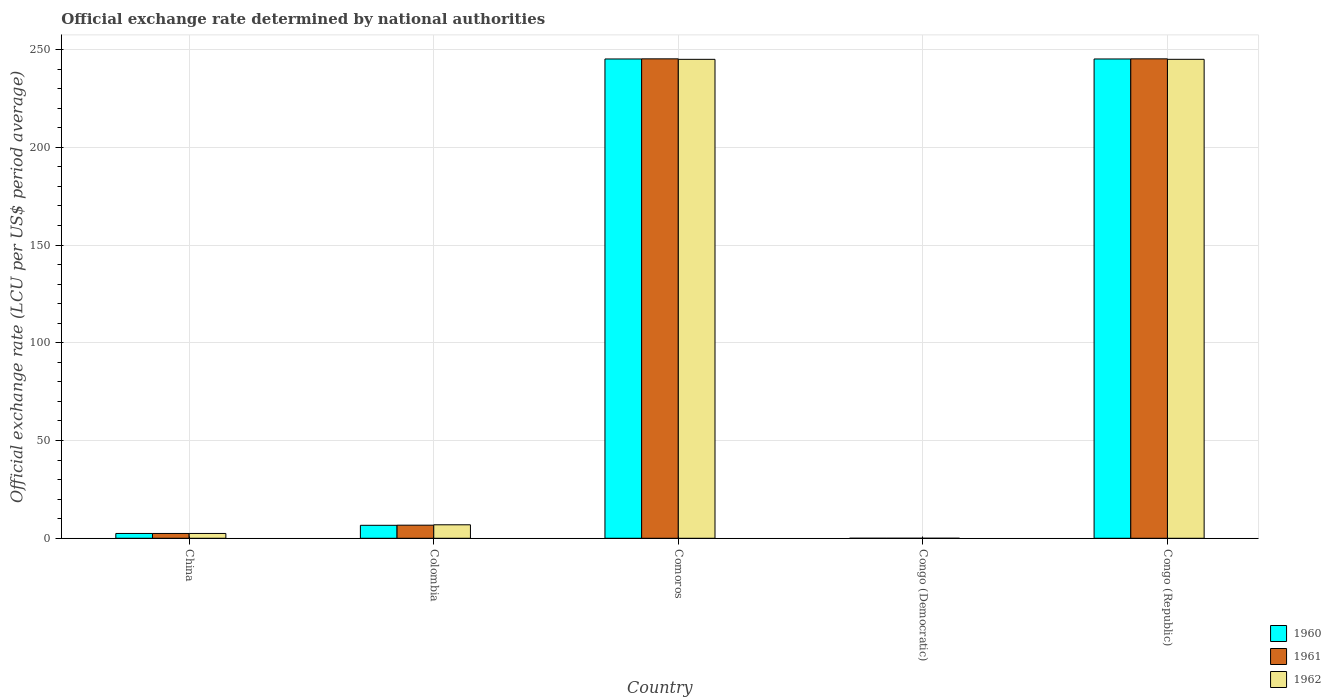How many different coloured bars are there?
Make the answer very short. 3. Are the number of bars on each tick of the X-axis equal?
Your answer should be very brief. Yes. How many bars are there on the 5th tick from the right?
Keep it short and to the point. 3. What is the label of the 2nd group of bars from the left?
Make the answer very short. Colombia. In how many cases, is the number of bars for a given country not equal to the number of legend labels?
Your response must be concise. 0. What is the official exchange rate in 1962 in China?
Your answer should be compact. 2.46. Across all countries, what is the maximum official exchange rate in 1961?
Your answer should be compact. 245.26. Across all countries, what is the minimum official exchange rate in 1960?
Keep it short and to the point. 1.7e-13. In which country was the official exchange rate in 1960 maximum?
Your answer should be compact. Congo (Republic). In which country was the official exchange rate in 1962 minimum?
Your answer should be compact. Congo (Democratic). What is the total official exchange rate in 1961 in the graph?
Offer a terse response. 499.68. What is the difference between the official exchange rate in 1960 in Congo (Democratic) and that in Congo (Republic)?
Your response must be concise. -245.2. What is the difference between the official exchange rate in 1961 in Congo (Democratic) and the official exchange rate in 1960 in Comoros?
Keep it short and to the point. -245.19. What is the average official exchange rate in 1962 per country?
Provide a succinct answer. 99.88. What is the ratio of the official exchange rate in 1960 in China to that in Congo (Republic)?
Make the answer very short. 0.01. Is the official exchange rate in 1960 in Colombia less than that in Congo (Democratic)?
Your answer should be very brief. No. What is the difference between the highest and the second highest official exchange rate in 1962?
Offer a very short reply. -0. What is the difference between the highest and the lowest official exchange rate in 1961?
Your answer should be compact. 245.26. In how many countries, is the official exchange rate in 1960 greater than the average official exchange rate in 1960 taken over all countries?
Provide a short and direct response. 2. What does the 1st bar from the left in China represents?
Give a very brief answer. 1960. What does the 3rd bar from the right in China represents?
Make the answer very short. 1960. Is it the case that in every country, the sum of the official exchange rate in 1961 and official exchange rate in 1962 is greater than the official exchange rate in 1960?
Your answer should be compact. Yes. How many bars are there?
Your response must be concise. 15. Are all the bars in the graph horizontal?
Keep it short and to the point. No. How many countries are there in the graph?
Offer a very short reply. 5. Are the values on the major ticks of Y-axis written in scientific E-notation?
Make the answer very short. No. Where does the legend appear in the graph?
Your answer should be compact. Bottom right. How are the legend labels stacked?
Ensure brevity in your answer.  Vertical. What is the title of the graph?
Make the answer very short. Official exchange rate determined by national authorities. Does "1973" appear as one of the legend labels in the graph?
Your response must be concise. No. What is the label or title of the X-axis?
Make the answer very short. Country. What is the label or title of the Y-axis?
Your answer should be very brief. Official exchange rate (LCU per US$ period average). What is the Official exchange rate (LCU per US$ period average) of 1960 in China?
Offer a very short reply. 2.46. What is the Official exchange rate (LCU per US$ period average) of 1961 in China?
Your answer should be very brief. 2.46. What is the Official exchange rate (LCU per US$ period average) of 1962 in China?
Offer a very short reply. 2.46. What is the Official exchange rate (LCU per US$ period average) in 1960 in Colombia?
Your answer should be compact. 6.63. What is the Official exchange rate (LCU per US$ period average) of 1961 in Colombia?
Offer a terse response. 6.7. What is the Official exchange rate (LCU per US$ period average) of 1962 in Colombia?
Make the answer very short. 6.9. What is the Official exchange rate (LCU per US$ period average) in 1960 in Comoros?
Your response must be concise. 245.19. What is the Official exchange rate (LCU per US$ period average) of 1961 in Comoros?
Provide a short and direct response. 245.26. What is the Official exchange rate (LCU per US$ period average) in 1962 in Comoros?
Provide a short and direct response. 245.01. What is the Official exchange rate (LCU per US$ period average) of 1960 in Congo (Democratic)?
Make the answer very short. 1.7e-13. What is the Official exchange rate (LCU per US$ period average) of 1961 in Congo (Democratic)?
Your answer should be very brief. 1.75e-13. What is the Official exchange rate (LCU per US$ period average) of 1962 in Congo (Democratic)?
Your answer should be very brief. 2.1e-13. What is the Official exchange rate (LCU per US$ period average) in 1960 in Congo (Republic)?
Your answer should be very brief. 245.2. What is the Official exchange rate (LCU per US$ period average) in 1961 in Congo (Republic)?
Provide a succinct answer. 245.26. What is the Official exchange rate (LCU per US$ period average) of 1962 in Congo (Republic)?
Your answer should be compact. 245.01. Across all countries, what is the maximum Official exchange rate (LCU per US$ period average) of 1960?
Give a very brief answer. 245.2. Across all countries, what is the maximum Official exchange rate (LCU per US$ period average) in 1961?
Give a very brief answer. 245.26. Across all countries, what is the maximum Official exchange rate (LCU per US$ period average) of 1962?
Provide a succinct answer. 245.01. Across all countries, what is the minimum Official exchange rate (LCU per US$ period average) of 1960?
Offer a terse response. 1.7e-13. Across all countries, what is the minimum Official exchange rate (LCU per US$ period average) in 1961?
Your answer should be compact. 1.75e-13. Across all countries, what is the minimum Official exchange rate (LCU per US$ period average) in 1962?
Provide a short and direct response. 2.1e-13. What is the total Official exchange rate (LCU per US$ period average) of 1960 in the graph?
Make the answer very short. 499.48. What is the total Official exchange rate (LCU per US$ period average) in 1961 in the graph?
Your answer should be very brief. 499.68. What is the total Official exchange rate (LCU per US$ period average) in 1962 in the graph?
Your response must be concise. 499.39. What is the difference between the Official exchange rate (LCU per US$ period average) of 1960 in China and that in Colombia?
Ensure brevity in your answer.  -4.17. What is the difference between the Official exchange rate (LCU per US$ period average) of 1961 in China and that in Colombia?
Your response must be concise. -4.24. What is the difference between the Official exchange rate (LCU per US$ period average) in 1962 in China and that in Colombia?
Make the answer very short. -4.44. What is the difference between the Official exchange rate (LCU per US$ period average) in 1960 in China and that in Comoros?
Ensure brevity in your answer.  -242.73. What is the difference between the Official exchange rate (LCU per US$ period average) of 1961 in China and that in Comoros?
Make the answer very short. -242.8. What is the difference between the Official exchange rate (LCU per US$ period average) of 1962 in China and that in Comoros?
Ensure brevity in your answer.  -242.55. What is the difference between the Official exchange rate (LCU per US$ period average) in 1960 in China and that in Congo (Democratic)?
Offer a terse response. 2.46. What is the difference between the Official exchange rate (LCU per US$ period average) in 1961 in China and that in Congo (Democratic)?
Provide a succinct answer. 2.46. What is the difference between the Official exchange rate (LCU per US$ period average) in 1962 in China and that in Congo (Democratic)?
Your response must be concise. 2.46. What is the difference between the Official exchange rate (LCU per US$ period average) in 1960 in China and that in Congo (Republic)?
Offer a terse response. -242.73. What is the difference between the Official exchange rate (LCU per US$ period average) of 1961 in China and that in Congo (Republic)?
Make the answer very short. -242.8. What is the difference between the Official exchange rate (LCU per US$ period average) in 1962 in China and that in Congo (Republic)?
Give a very brief answer. -242.55. What is the difference between the Official exchange rate (LCU per US$ period average) of 1960 in Colombia and that in Comoros?
Provide a succinct answer. -238.56. What is the difference between the Official exchange rate (LCU per US$ period average) of 1961 in Colombia and that in Comoros?
Offer a very short reply. -238.56. What is the difference between the Official exchange rate (LCU per US$ period average) of 1962 in Colombia and that in Comoros?
Provide a short and direct response. -238.11. What is the difference between the Official exchange rate (LCU per US$ period average) of 1960 in Colombia and that in Congo (Democratic)?
Offer a terse response. 6.63. What is the difference between the Official exchange rate (LCU per US$ period average) of 1961 in Colombia and that in Congo (Democratic)?
Your answer should be very brief. 6.7. What is the difference between the Official exchange rate (LCU per US$ period average) of 1962 in Colombia and that in Congo (Democratic)?
Your answer should be compact. 6.9. What is the difference between the Official exchange rate (LCU per US$ period average) of 1960 in Colombia and that in Congo (Republic)?
Offer a terse response. -238.56. What is the difference between the Official exchange rate (LCU per US$ period average) of 1961 in Colombia and that in Congo (Republic)?
Give a very brief answer. -238.56. What is the difference between the Official exchange rate (LCU per US$ period average) of 1962 in Colombia and that in Congo (Republic)?
Your answer should be very brief. -238.11. What is the difference between the Official exchange rate (LCU per US$ period average) in 1960 in Comoros and that in Congo (Democratic)?
Your response must be concise. 245.19. What is the difference between the Official exchange rate (LCU per US$ period average) of 1961 in Comoros and that in Congo (Democratic)?
Provide a short and direct response. 245.26. What is the difference between the Official exchange rate (LCU per US$ period average) of 1962 in Comoros and that in Congo (Democratic)?
Make the answer very short. 245.01. What is the difference between the Official exchange rate (LCU per US$ period average) in 1960 in Comoros and that in Congo (Republic)?
Give a very brief answer. -0. What is the difference between the Official exchange rate (LCU per US$ period average) of 1961 in Comoros and that in Congo (Republic)?
Your response must be concise. -0. What is the difference between the Official exchange rate (LCU per US$ period average) of 1962 in Comoros and that in Congo (Republic)?
Your answer should be very brief. -0. What is the difference between the Official exchange rate (LCU per US$ period average) in 1960 in Congo (Democratic) and that in Congo (Republic)?
Offer a very short reply. -245.2. What is the difference between the Official exchange rate (LCU per US$ period average) of 1961 in Congo (Democratic) and that in Congo (Republic)?
Your answer should be compact. -245.26. What is the difference between the Official exchange rate (LCU per US$ period average) in 1962 in Congo (Democratic) and that in Congo (Republic)?
Keep it short and to the point. -245.01. What is the difference between the Official exchange rate (LCU per US$ period average) of 1960 in China and the Official exchange rate (LCU per US$ period average) of 1961 in Colombia?
Provide a succinct answer. -4.24. What is the difference between the Official exchange rate (LCU per US$ period average) in 1960 in China and the Official exchange rate (LCU per US$ period average) in 1962 in Colombia?
Provide a succinct answer. -4.44. What is the difference between the Official exchange rate (LCU per US$ period average) in 1961 in China and the Official exchange rate (LCU per US$ period average) in 1962 in Colombia?
Your answer should be very brief. -4.44. What is the difference between the Official exchange rate (LCU per US$ period average) in 1960 in China and the Official exchange rate (LCU per US$ period average) in 1961 in Comoros?
Your response must be concise. -242.8. What is the difference between the Official exchange rate (LCU per US$ period average) of 1960 in China and the Official exchange rate (LCU per US$ period average) of 1962 in Comoros?
Provide a short and direct response. -242.55. What is the difference between the Official exchange rate (LCU per US$ period average) of 1961 in China and the Official exchange rate (LCU per US$ period average) of 1962 in Comoros?
Offer a very short reply. -242.55. What is the difference between the Official exchange rate (LCU per US$ period average) of 1960 in China and the Official exchange rate (LCU per US$ period average) of 1961 in Congo (Democratic)?
Keep it short and to the point. 2.46. What is the difference between the Official exchange rate (LCU per US$ period average) in 1960 in China and the Official exchange rate (LCU per US$ period average) in 1962 in Congo (Democratic)?
Offer a terse response. 2.46. What is the difference between the Official exchange rate (LCU per US$ period average) in 1961 in China and the Official exchange rate (LCU per US$ period average) in 1962 in Congo (Democratic)?
Keep it short and to the point. 2.46. What is the difference between the Official exchange rate (LCU per US$ period average) of 1960 in China and the Official exchange rate (LCU per US$ period average) of 1961 in Congo (Republic)?
Your answer should be compact. -242.8. What is the difference between the Official exchange rate (LCU per US$ period average) in 1960 in China and the Official exchange rate (LCU per US$ period average) in 1962 in Congo (Republic)?
Keep it short and to the point. -242.55. What is the difference between the Official exchange rate (LCU per US$ period average) of 1961 in China and the Official exchange rate (LCU per US$ period average) of 1962 in Congo (Republic)?
Provide a succinct answer. -242.55. What is the difference between the Official exchange rate (LCU per US$ period average) in 1960 in Colombia and the Official exchange rate (LCU per US$ period average) in 1961 in Comoros?
Give a very brief answer. -238.62. What is the difference between the Official exchange rate (LCU per US$ period average) in 1960 in Colombia and the Official exchange rate (LCU per US$ period average) in 1962 in Comoros?
Offer a terse response. -238.38. What is the difference between the Official exchange rate (LCU per US$ period average) of 1961 in Colombia and the Official exchange rate (LCU per US$ period average) of 1962 in Comoros?
Ensure brevity in your answer.  -238.31. What is the difference between the Official exchange rate (LCU per US$ period average) in 1960 in Colombia and the Official exchange rate (LCU per US$ period average) in 1961 in Congo (Democratic)?
Provide a short and direct response. 6.63. What is the difference between the Official exchange rate (LCU per US$ period average) in 1960 in Colombia and the Official exchange rate (LCU per US$ period average) in 1962 in Congo (Democratic)?
Offer a terse response. 6.63. What is the difference between the Official exchange rate (LCU per US$ period average) of 1960 in Colombia and the Official exchange rate (LCU per US$ period average) of 1961 in Congo (Republic)?
Provide a succinct answer. -238.63. What is the difference between the Official exchange rate (LCU per US$ period average) in 1960 in Colombia and the Official exchange rate (LCU per US$ period average) in 1962 in Congo (Republic)?
Your response must be concise. -238.38. What is the difference between the Official exchange rate (LCU per US$ period average) in 1961 in Colombia and the Official exchange rate (LCU per US$ period average) in 1962 in Congo (Republic)?
Your answer should be very brief. -238.31. What is the difference between the Official exchange rate (LCU per US$ period average) of 1960 in Comoros and the Official exchange rate (LCU per US$ period average) of 1961 in Congo (Democratic)?
Offer a very short reply. 245.19. What is the difference between the Official exchange rate (LCU per US$ period average) of 1960 in Comoros and the Official exchange rate (LCU per US$ period average) of 1962 in Congo (Democratic)?
Ensure brevity in your answer.  245.19. What is the difference between the Official exchange rate (LCU per US$ period average) of 1961 in Comoros and the Official exchange rate (LCU per US$ period average) of 1962 in Congo (Democratic)?
Give a very brief answer. 245.26. What is the difference between the Official exchange rate (LCU per US$ period average) in 1960 in Comoros and the Official exchange rate (LCU per US$ period average) in 1961 in Congo (Republic)?
Provide a short and direct response. -0.07. What is the difference between the Official exchange rate (LCU per US$ period average) in 1960 in Comoros and the Official exchange rate (LCU per US$ period average) in 1962 in Congo (Republic)?
Your answer should be very brief. 0.18. What is the difference between the Official exchange rate (LCU per US$ period average) of 1961 in Comoros and the Official exchange rate (LCU per US$ period average) of 1962 in Congo (Republic)?
Make the answer very short. 0.24. What is the difference between the Official exchange rate (LCU per US$ period average) of 1960 in Congo (Democratic) and the Official exchange rate (LCU per US$ period average) of 1961 in Congo (Republic)?
Provide a succinct answer. -245.26. What is the difference between the Official exchange rate (LCU per US$ period average) of 1960 in Congo (Democratic) and the Official exchange rate (LCU per US$ period average) of 1962 in Congo (Republic)?
Offer a terse response. -245.01. What is the difference between the Official exchange rate (LCU per US$ period average) in 1961 in Congo (Democratic) and the Official exchange rate (LCU per US$ period average) in 1962 in Congo (Republic)?
Give a very brief answer. -245.01. What is the average Official exchange rate (LCU per US$ period average) in 1960 per country?
Offer a terse response. 99.9. What is the average Official exchange rate (LCU per US$ period average) of 1961 per country?
Your answer should be very brief. 99.94. What is the average Official exchange rate (LCU per US$ period average) in 1962 per country?
Provide a short and direct response. 99.88. What is the difference between the Official exchange rate (LCU per US$ period average) in 1960 and Official exchange rate (LCU per US$ period average) in 1961 in China?
Make the answer very short. 0. What is the difference between the Official exchange rate (LCU per US$ period average) of 1960 and Official exchange rate (LCU per US$ period average) of 1962 in China?
Offer a very short reply. 0. What is the difference between the Official exchange rate (LCU per US$ period average) in 1960 and Official exchange rate (LCU per US$ period average) in 1961 in Colombia?
Offer a terse response. -0.07. What is the difference between the Official exchange rate (LCU per US$ period average) of 1960 and Official exchange rate (LCU per US$ period average) of 1962 in Colombia?
Your answer should be compact. -0.27. What is the difference between the Official exchange rate (LCU per US$ period average) in 1961 and Official exchange rate (LCU per US$ period average) in 1962 in Colombia?
Offer a terse response. -0.2. What is the difference between the Official exchange rate (LCU per US$ period average) of 1960 and Official exchange rate (LCU per US$ period average) of 1961 in Comoros?
Keep it short and to the point. -0.07. What is the difference between the Official exchange rate (LCU per US$ period average) of 1960 and Official exchange rate (LCU per US$ period average) of 1962 in Comoros?
Keep it short and to the point. 0.18. What is the difference between the Official exchange rate (LCU per US$ period average) of 1961 and Official exchange rate (LCU per US$ period average) of 1962 in Comoros?
Your answer should be compact. 0.25. What is the difference between the Official exchange rate (LCU per US$ period average) of 1960 and Official exchange rate (LCU per US$ period average) of 1962 in Congo (Democratic)?
Your answer should be very brief. -0. What is the difference between the Official exchange rate (LCU per US$ period average) of 1960 and Official exchange rate (LCU per US$ period average) of 1961 in Congo (Republic)?
Provide a succinct answer. -0.07. What is the difference between the Official exchange rate (LCU per US$ period average) of 1960 and Official exchange rate (LCU per US$ period average) of 1962 in Congo (Republic)?
Your answer should be very brief. 0.18. What is the difference between the Official exchange rate (LCU per US$ period average) of 1961 and Official exchange rate (LCU per US$ period average) of 1962 in Congo (Republic)?
Your answer should be very brief. 0.25. What is the ratio of the Official exchange rate (LCU per US$ period average) in 1960 in China to that in Colombia?
Your response must be concise. 0.37. What is the ratio of the Official exchange rate (LCU per US$ period average) in 1961 in China to that in Colombia?
Provide a succinct answer. 0.37. What is the ratio of the Official exchange rate (LCU per US$ period average) of 1962 in China to that in Colombia?
Give a very brief answer. 0.36. What is the ratio of the Official exchange rate (LCU per US$ period average) in 1960 in China to that in Congo (Democratic)?
Your answer should be very brief. 1.45e+13. What is the ratio of the Official exchange rate (LCU per US$ period average) in 1961 in China to that in Congo (Democratic)?
Provide a succinct answer. 1.41e+13. What is the ratio of the Official exchange rate (LCU per US$ period average) in 1962 in China to that in Congo (Democratic)?
Keep it short and to the point. 1.17e+13. What is the ratio of the Official exchange rate (LCU per US$ period average) of 1962 in China to that in Congo (Republic)?
Make the answer very short. 0.01. What is the ratio of the Official exchange rate (LCU per US$ period average) of 1960 in Colombia to that in Comoros?
Keep it short and to the point. 0.03. What is the ratio of the Official exchange rate (LCU per US$ period average) of 1961 in Colombia to that in Comoros?
Keep it short and to the point. 0.03. What is the ratio of the Official exchange rate (LCU per US$ period average) of 1962 in Colombia to that in Comoros?
Give a very brief answer. 0.03. What is the ratio of the Official exchange rate (LCU per US$ period average) in 1960 in Colombia to that in Congo (Democratic)?
Offer a terse response. 3.90e+13. What is the ratio of the Official exchange rate (LCU per US$ period average) in 1961 in Colombia to that in Congo (Democratic)?
Your answer should be very brief. 3.83e+13. What is the ratio of the Official exchange rate (LCU per US$ period average) of 1962 in Colombia to that in Congo (Democratic)?
Make the answer very short. 3.29e+13. What is the ratio of the Official exchange rate (LCU per US$ period average) in 1960 in Colombia to that in Congo (Republic)?
Make the answer very short. 0.03. What is the ratio of the Official exchange rate (LCU per US$ period average) of 1961 in Colombia to that in Congo (Republic)?
Your response must be concise. 0.03. What is the ratio of the Official exchange rate (LCU per US$ period average) of 1962 in Colombia to that in Congo (Republic)?
Make the answer very short. 0.03. What is the ratio of the Official exchange rate (LCU per US$ period average) of 1960 in Comoros to that in Congo (Democratic)?
Give a very brief answer. 1.44e+15. What is the ratio of the Official exchange rate (LCU per US$ period average) in 1961 in Comoros to that in Congo (Democratic)?
Provide a succinct answer. 1.40e+15. What is the ratio of the Official exchange rate (LCU per US$ period average) of 1962 in Comoros to that in Congo (Democratic)?
Your answer should be very brief. 1.17e+15. What is the ratio of the Official exchange rate (LCU per US$ period average) of 1962 in Comoros to that in Congo (Republic)?
Your response must be concise. 1. What is the ratio of the Official exchange rate (LCU per US$ period average) of 1960 in Congo (Democratic) to that in Congo (Republic)?
Give a very brief answer. 0. What is the ratio of the Official exchange rate (LCU per US$ period average) of 1962 in Congo (Democratic) to that in Congo (Republic)?
Make the answer very short. 0. What is the difference between the highest and the second highest Official exchange rate (LCU per US$ period average) in 1960?
Provide a succinct answer. 0. What is the difference between the highest and the second highest Official exchange rate (LCU per US$ period average) in 1961?
Make the answer very short. 0. What is the difference between the highest and the second highest Official exchange rate (LCU per US$ period average) in 1962?
Ensure brevity in your answer.  0. What is the difference between the highest and the lowest Official exchange rate (LCU per US$ period average) in 1960?
Offer a very short reply. 245.2. What is the difference between the highest and the lowest Official exchange rate (LCU per US$ period average) in 1961?
Ensure brevity in your answer.  245.26. What is the difference between the highest and the lowest Official exchange rate (LCU per US$ period average) in 1962?
Your answer should be compact. 245.01. 